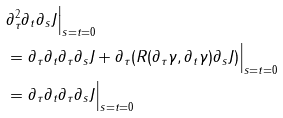<formula> <loc_0><loc_0><loc_500><loc_500>& \partial _ { \tau } ^ { 2 } \partial _ { t } \partial _ { s } J \Big | _ { s = t = 0 } \\ & = \partial _ { \tau } \partial _ { t } \partial _ { \tau } \partial _ { s } J + \partial _ { \tau } ( R ( \partial _ { \tau } \gamma , \partial _ { t } \gamma ) \partial _ { s } J ) \Big | _ { s = t = 0 } \\ & = \partial _ { \tau } \partial _ { t } \partial _ { \tau } \partial _ { s } J \Big | _ { s = t = 0 } \\</formula> 